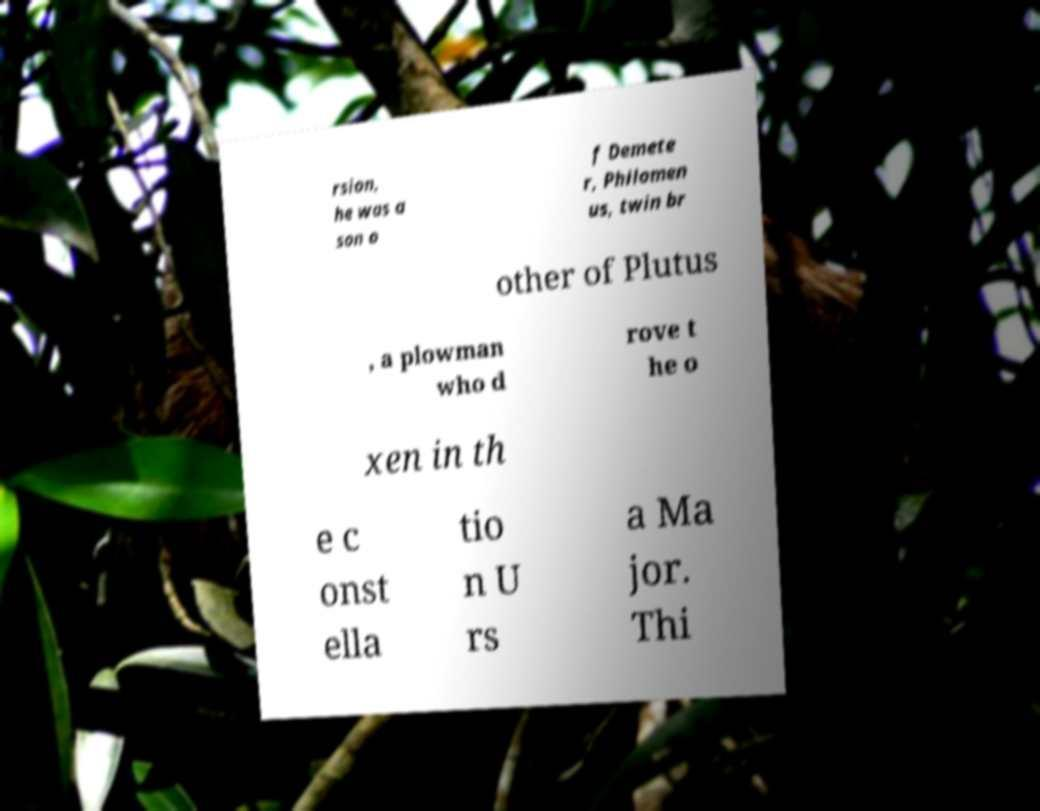Please identify and transcribe the text found in this image. rsion, he was a son o f Demete r, Philomen us, twin br other of Plutus , a plowman who d rove t he o xen in th e c onst ella tio n U rs a Ma jor. Thi 